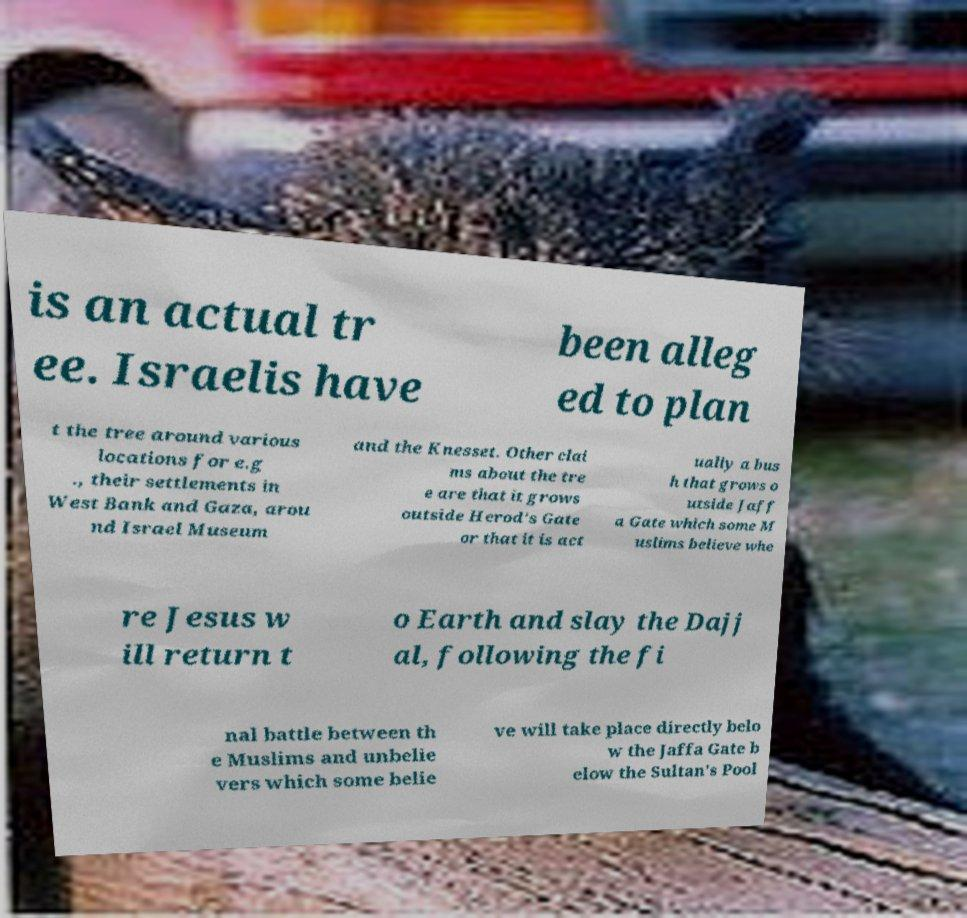There's text embedded in this image that I need extracted. Can you transcribe it verbatim? is an actual tr ee. Israelis have been alleg ed to plan t the tree around various locations for e.g ., their settlements in West Bank and Gaza, arou nd Israel Museum and the Knesset. Other clai ms about the tre e are that it grows outside Herod's Gate or that it is act ually a bus h that grows o utside Jaff a Gate which some M uslims believe whe re Jesus w ill return t o Earth and slay the Dajj al, following the fi nal battle between th e Muslims and unbelie vers which some belie ve will take place directly belo w the Jaffa Gate b elow the Sultan's Pool 